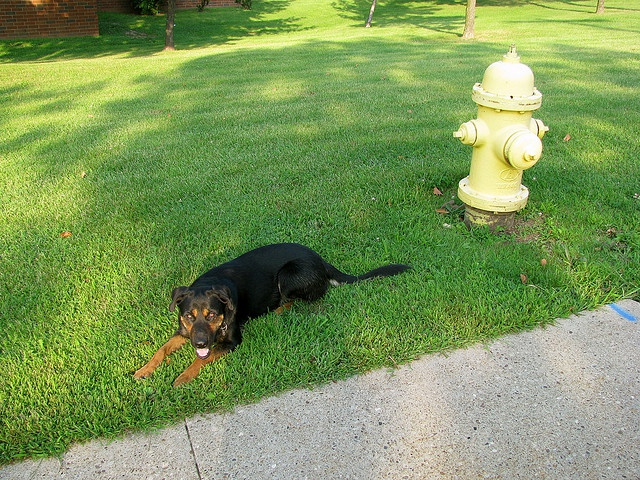Describe the objects in this image and their specific colors. I can see dog in black, darkgreen, gray, and olive tones and fire hydrant in black, khaki, beige, and olive tones in this image. 